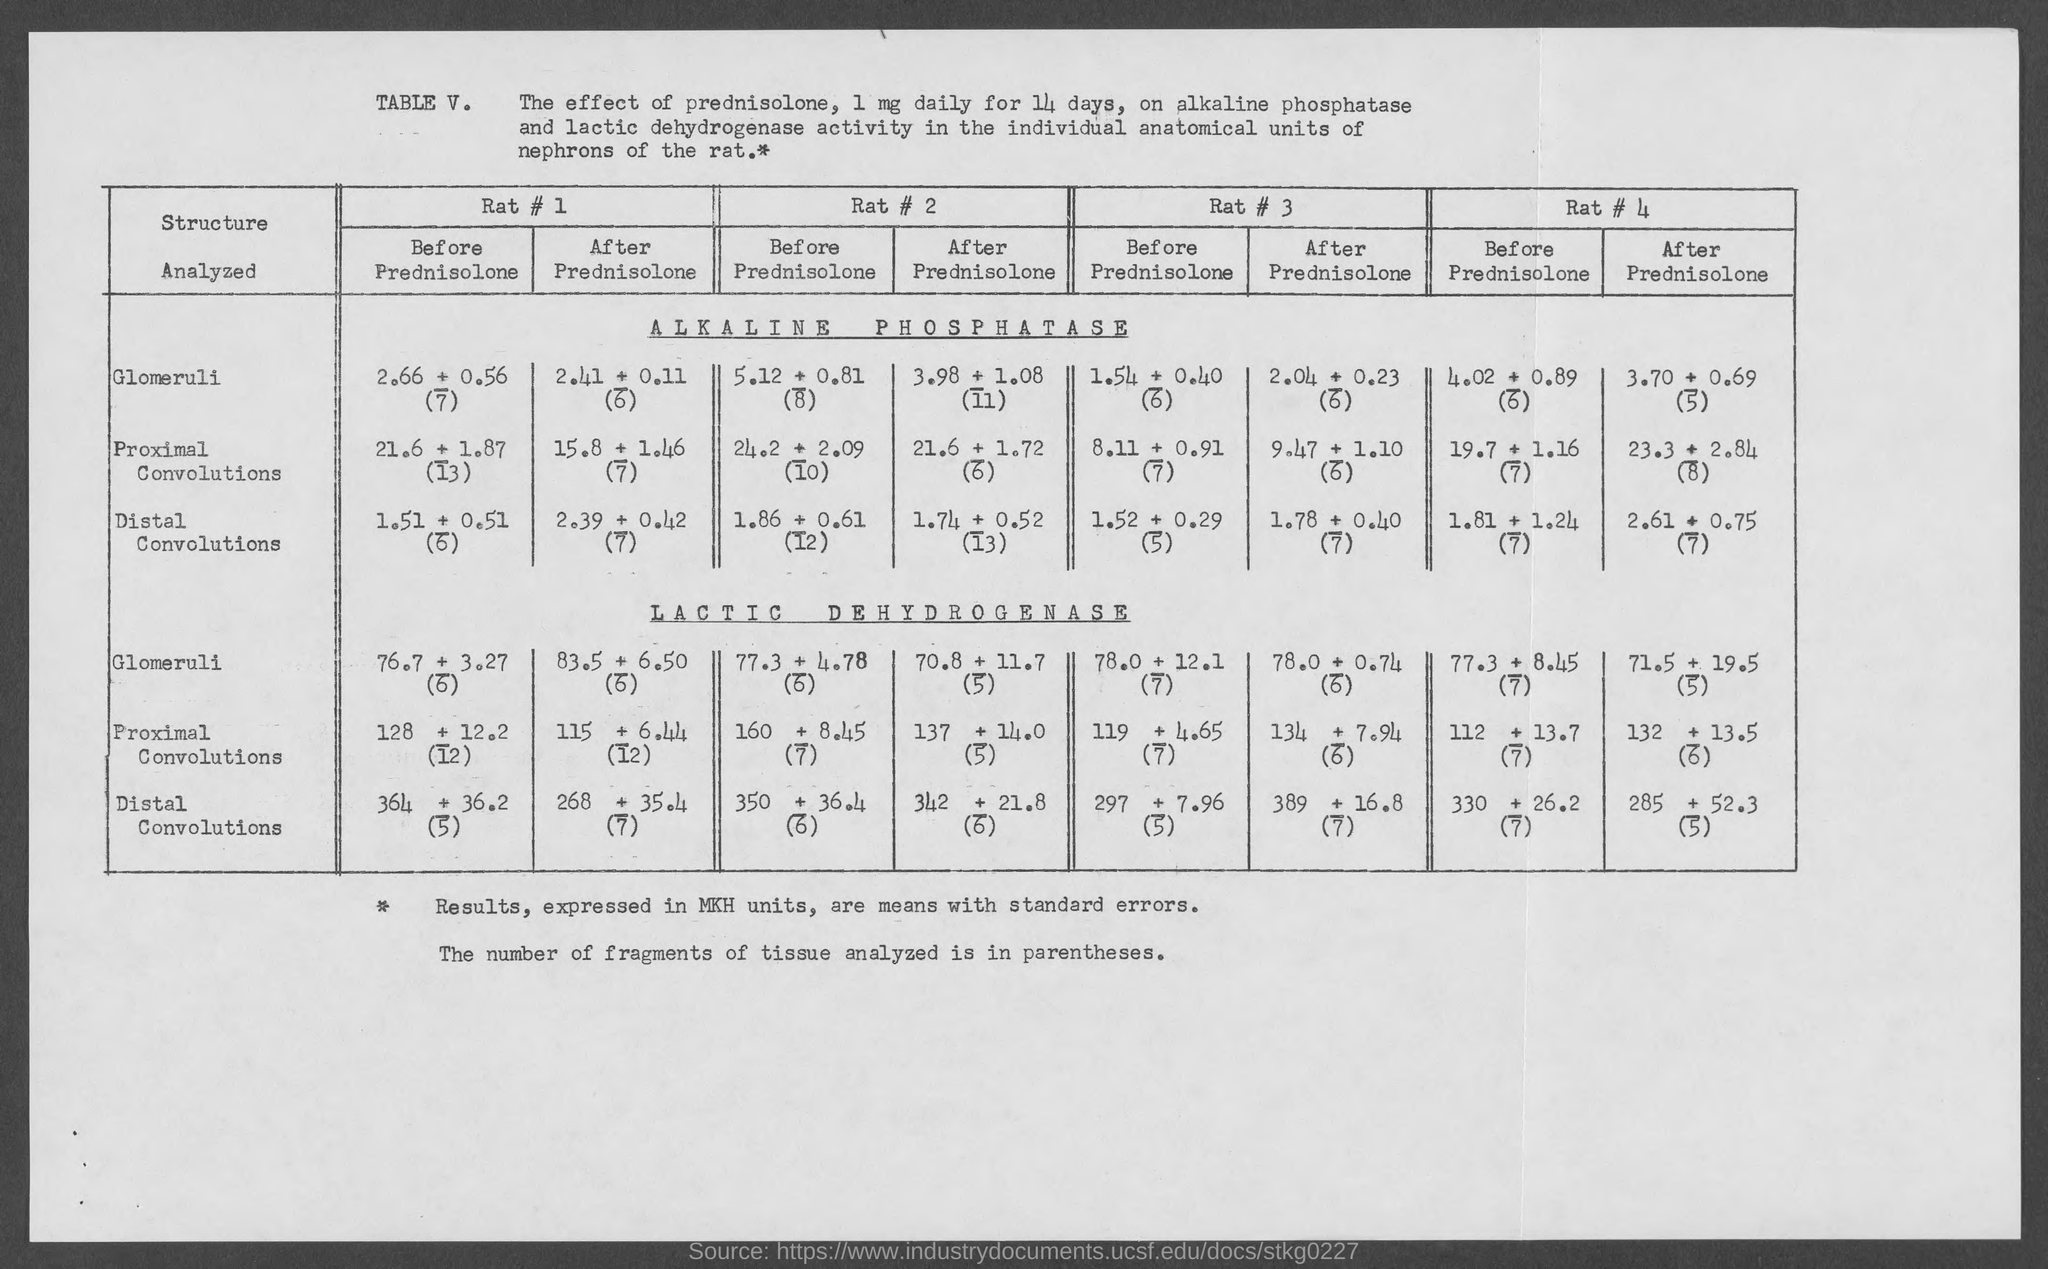What is the table no.?
Your answer should be very brief. V. 